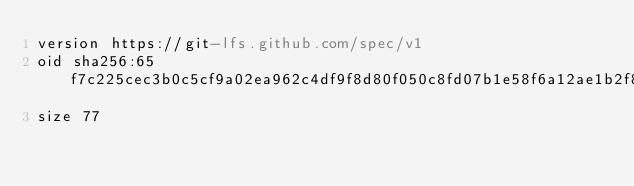<code> <loc_0><loc_0><loc_500><loc_500><_YAML_>version https://git-lfs.github.com/spec/v1
oid sha256:65f7c225cec3b0c5cf9a02ea962c4df9f8d80f050c8fd07b1e58f6a12ae1b2f8
size 77
</code> 